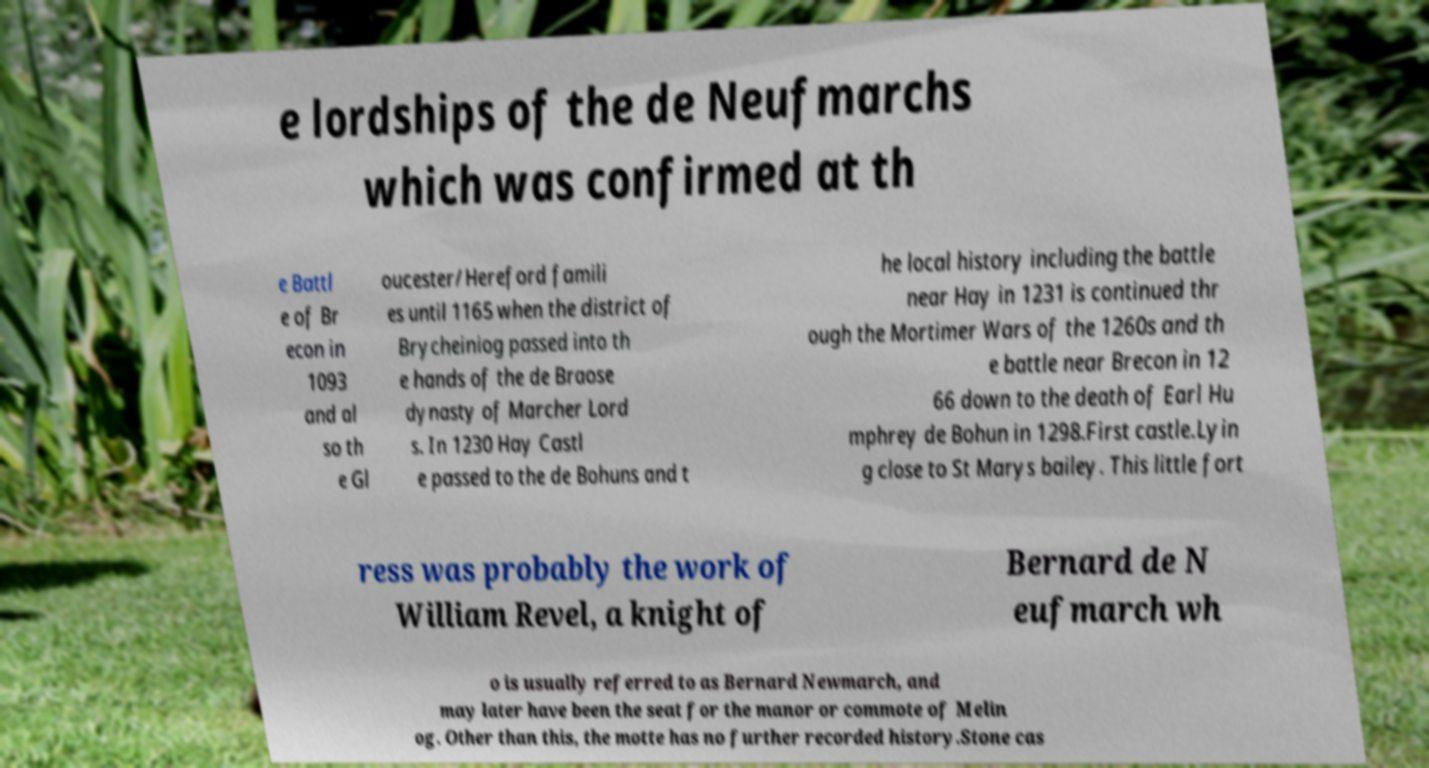Can you read and provide the text displayed in the image?This photo seems to have some interesting text. Can you extract and type it out for me? e lordships of the de Neufmarchs which was confirmed at th e Battl e of Br econ in 1093 and al so th e Gl oucester/Hereford famili es until 1165 when the district of Brycheiniog passed into th e hands of the de Braose dynasty of Marcher Lord s. In 1230 Hay Castl e passed to the de Bohuns and t he local history including the battle near Hay in 1231 is continued thr ough the Mortimer Wars of the 1260s and th e battle near Brecon in 12 66 down to the death of Earl Hu mphrey de Bohun in 1298.First castle.Lyin g close to St Marys bailey. This little fort ress was probably the work of William Revel, a knight of Bernard de N eufmarch wh o is usually referred to as Bernard Newmarch, and may later have been the seat for the manor or commote of Melin og. Other than this, the motte has no further recorded history.Stone cas 